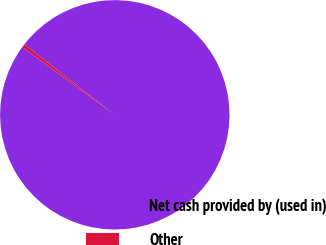Convert chart. <chart><loc_0><loc_0><loc_500><loc_500><pie_chart><fcel>Net cash provided by (used in)<fcel>Other<nl><fcel>99.54%<fcel>0.46%<nl></chart> 